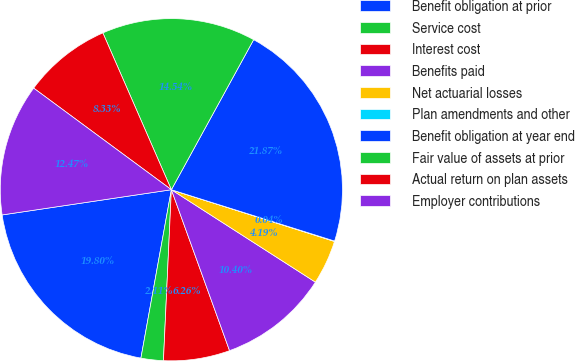Convert chart. <chart><loc_0><loc_0><loc_500><loc_500><pie_chart><fcel>Benefit obligation at prior<fcel>Service cost<fcel>Interest cost<fcel>Benefits paid<fcel>Net actuarial losses<fcel>Plan amendments and other<fcel>Benefit obligation at year end<fcel>Fair value of assets at prior<fcel>Actual return on plan assets<fcel>Employer contributions<nl><fcel>19.8%<fcel>2.11%<fcel>6.26%<fcel>10.4%<fcel>4.19%<fcel>0.04%<fcel>21.87%<fcel>14.54%<fcel>8.33%<fcel>12.47%<nl></chart> 